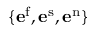<formula> <loc_0><loc_0><loc_500><loc_500>\{ e ^ { f } , e ^ { s } , e ^ { n } \}</formula> 